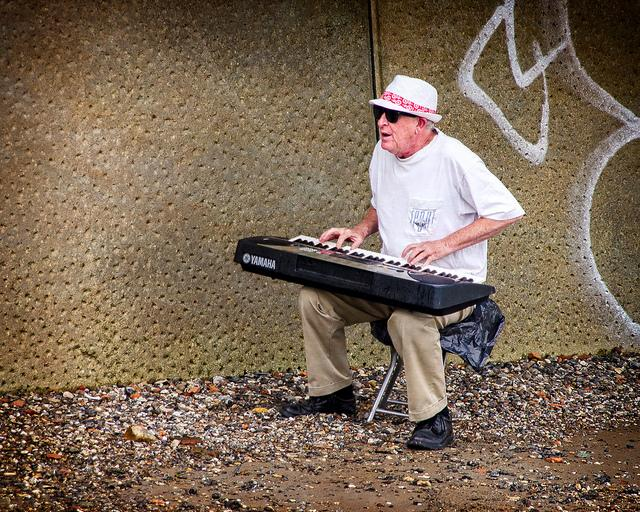What powers the musical instrument shown here? Please explain your reasoning. battery. There are no cords attached to the instrument. 